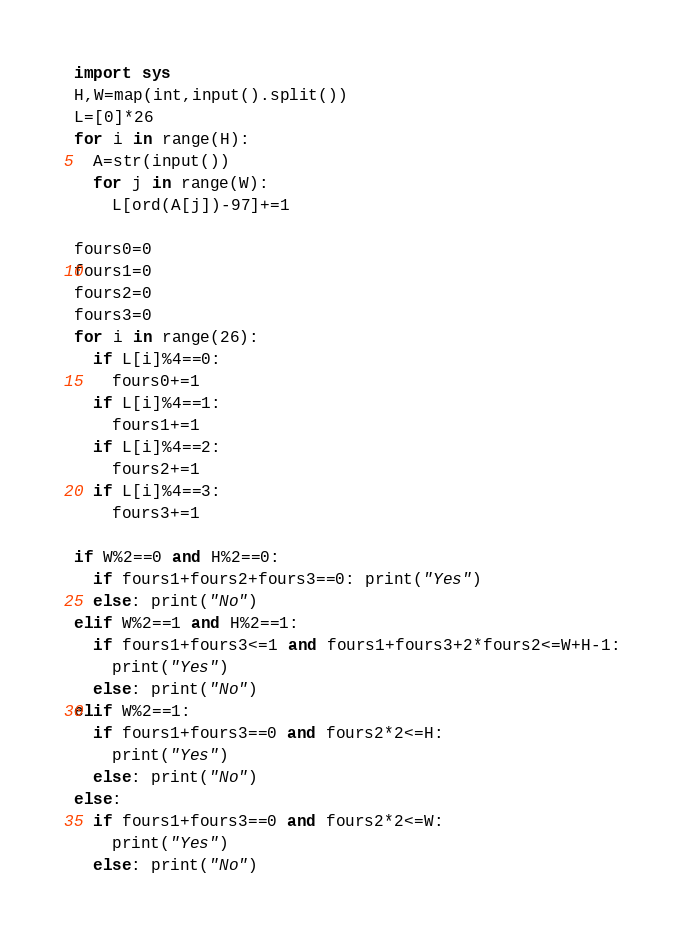Convert code to text. <code><loc_0><loc_0><loc_500><loc_500><_Python_>import sys
H,W=map(int,input().split())
L=[0]*26
for i in range(H):
  A=str(input())
  for j in range(W):
    L[ord(A[j])-97]+=1

fours0=0
fours1=0
fours2=0
fours3=0
for i in range(26):
  if L[i]%4==0:
    fours0+=1
  if L[i]%4==1:
    fours1+=1
  if L[i]%4==2:
    fours2+=1
  if L[i]%4==3:
    fours3+=1

if W%2==0 and H%2==0:
  if fours1+fours2+fours3==0: print("Yes")
  else: print("No")
elif W%2==1 and H%2==1:
  if fours1+fours3<=1 and fours1+fours3+2*fours2<=W+H-1:
    print("Yes")
  else: print("No")
elif W%2==1: 
  if fours1+fours3==0 and fours2*2<=H:
    print("Yes")
  else: print("No")
else: 
  if fours1+fours3==0 and fours2*2<=W:
    print("Yes")
  else: print("No")</code> 